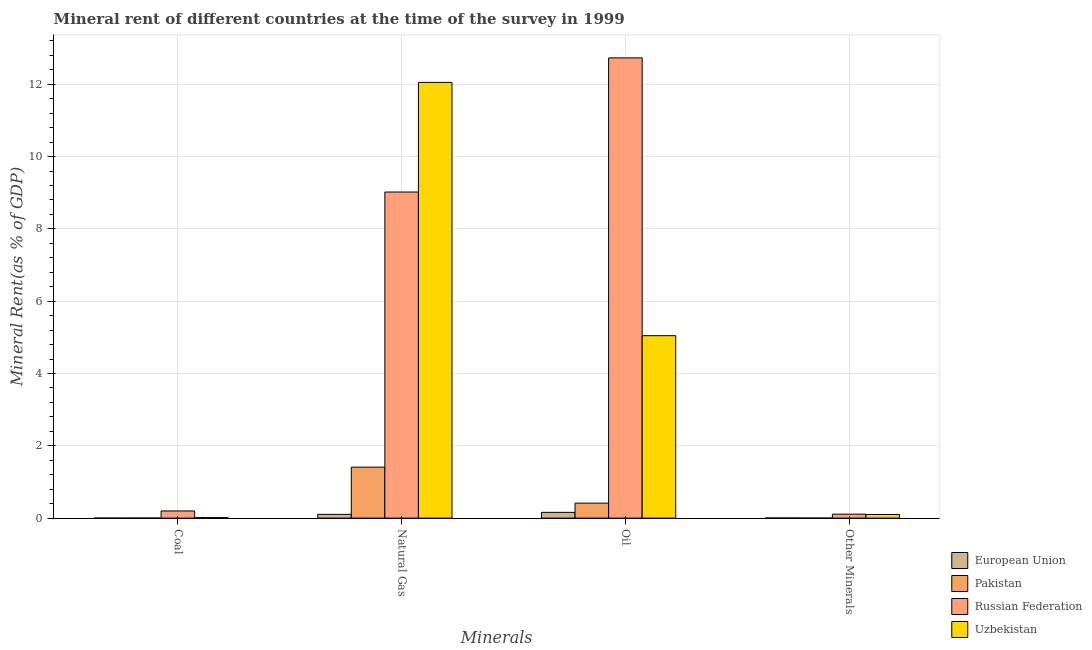How many different coloured bars are there?
Ensure brevity in your answer.  4. Are the number of bars per tick equal to the number of legend labels?
Make the answer very short. Yes. Are the number of bars on each tick of the X-axis equal?
Provide a succinct answer. Yes. How many bars are there on the 4th tick from the left?
Make the answer very short. 4. How many bars are there on the 3rd tick from the right?
Make the answer very short. 4. What is the label of the 4th group of bars from the left?
Keep it short and to the point. Other Minerals. What is the coal rent in Uzbekistan?
Your answer should be compact. 0.01. Across all countries, what is the maximum coal rent?
Your answer should be compact. 0.2. Across all countries, what is the minimum  rent of other minerals?
Your answer should be compact. 0. In which country was the oil rent maximum?
Offer a very short reply. Russian Federation. What is the total oil rent in the graph?
Keep it short and to the point. 18.35. What is the difference between the oil rent in Uzbekistan and that in Pakistan?
Your answer should be compact. 4.63. What is the difference between the natural gas rent in Uzbekistan and the coal rent in Pakistan?
Offer a terse response. 12.05. What is the average  rent of other minerals per country?
Offer a terse response. 0.05. What is the difference between the natural gas rent and oil rent in Uzbekistan?
Keep it short and to the point. 7.01. What is the ratio of the natural gas rent in European Union to that in Uzbekistan?
Ensure brevity in your answer.  0.01. Is the difference between the coal rent in Uzbekistan and European Union greater than the difference between the oil rent in Uzbekistan and European Union?
Your response must be concise. No. What is the difference between the highest and the second highest  rent of other minerals?
Keep it short and to the point. 0.01. What is the difference between the highest and the lowest oil rent?
Offer a very short reply. 12.57. Is it the case that in every country, the sum of the  rent of other minerals and coal rent is greater than the sum of oil rent and natural gas rent?
Your answer should be very brief. No. What does the 3rd bar from the left in Coal represents?
Give a very brief answer. Russian Federation. What does the 1st bar from the right in Other Minerals represents?
Offer a terse response. Uzbekistan. Is it the case that in every country, the sum of the coal rent and natural gas rent is greater than the oil rent?
Provide a succinct answer. No. Are all the bars in the graph horizontal?
Provide a succinct answer. No. How many countries are there in the graph?
Offer a terse response. 4. Are the values on the major ticks of Y-axis written in scientific E-notation?
Your response must be concise. No. Does the graph contain any zero values?
Ensure brevity in your answer.  No. Does the graph contain grids?
Your answer should be very brief. Yes. Where does the legend appear in the graph?
Your response must be concise. Bottom right. What is the title of the graph?
Give a very brief answer. Mineral rent of different countries at the time of the survey in 1999. Does "St. Kitts and Nevis" appear as one of the legend labels in the graph?
Offer a terse response. No. What is the label or title of the X-axis?
Your response must be concise. Minerals. What is the label or title of the Y-axis?
Your response must be concise. Mineral Rent(as % of GDP). What is the Mineral Rent(as % of GDP) in European Union in Coal?
Your response must be concise. 7.968829103317441e-5. What is the Mineral Rent(as % of GDP) of Pakistan in Coal?
Your answer should be compact. 0. What is the Mineral Rent(as % of GDP) of Russian Federation in Coal?
Your response must be concise. 0.2. What is the Mineral Rent(as % of GDP) of Uzbekistan in Coal?
Your response must be concise. 0.01. What is the Mineral Rent(as % of GDP) in European Union in Natural Gas?
Keep it short and to the point. 0.1. What is the Mineral Rent(as % of GDP) in Pakistan in Natural Gas?
Provide a succinct answer. 1.41. What is the Mineral Rent(as % of GDP) of Russian Federation in Natural Gas?
Provide a short and direct response. 9.02. What is the Mineral Rent(as % of GDP) in Uzbekistan in Natural Gas?
Your answer should be compact. 12.05. What is the Mineral Rent(as % of GDP) of European Union in Oil?
Keep it short and to the point. 0.16. What is the Mineral Rent(as % of GDP) in Pakistan in Oil?
Ensure brevity in your answer.  0.41. What is the Mineral Rent(as % of GDP) in Russian Federation in Oil?
Keep it short and to the point. 12.73. What is the Mineral Rent(as % of GDP) in Uzbekistan in Oil?
Ensure brevity in your answer.  5.05. What is the Mineral Rent(as % of GDP) in European Union in Other Minerals?
Your response must be concise. 0. What is the Mineral Rent(as % of GDP) of Pakistan in Other Minerals?
Your answer should be compact. 0. What is the Mineral Rent(as % of GDP) in Russian Federation in Other Minerals?
Offer a terse response. 0.11. What is the Mineral Rent(as % of GDP) of Uzbekistan in Other Minerals?
Give a very brief answer. 0.1. Across all Minerals, what is the maximum Mineral Rent(as % of GDP) in European Union?
Your response must be concise. 0.16. Across all Minerals, what is the maximum Mineral Rent(as % of GDP) of Pakistan?
Your answer should be very brief. 1.41. Across all Minerals, what is the maximum Mineral Rent(as % of GDP) of Russian Federation?
Keep it short and to the point. 12.73. Across all Minerals, what is the maximum Mineral Rent(as % of GDP) in Uzbekistan?
Provide a succinct answer. 12.05. Across all Minerals, what is the minimum Mineral Rent(as % of GDP) of European Union?
Keep it short and to the point. 7.968829103317441e-5. Across all Minerals, what is the minimum Mineral Rent(as % of GDP) of Pakistan?
Make the answer very short. 0. Across all Minerals, what is the minimum Mineral Rent(as % of GDP) in Russian Federation?
Your answer should be compact. 0.11. Across all Minerals, what is the minimum Mineral Rent(as % of GDP) in Uzbekistan?
Ensure brevity in your answer.  0.01. What is the total Mineral Rent(as % of GDP) of European Union in the graph?
Offer a very short reply. 0.27. What is the total Mineral Rent(as % of GDP) of Pakistan in the graph?
Offer a terse response. 1.83. What is the total Mineral Rent(as % of GDP) of Russian Federation in the graph?
Provide a short and direct response. 22.06. What is the total Mineral Rent(as % of GDP) of Uzbekistan in the graph?
Give a very brief answer. 17.22. What is the difference between the Mineral Rent(as % of GDP) of European Union in Coal and that in Natural Gas?
Your response must be concise. -0.1. What is the difference between the Mineral Rent(as % of GDP) of Pakistan in Coal and that in Natural Gas?
Keep it short and to the point. -1.41. What is the difference between the Mineral Rent(as % of GDP) in Russian Federation in Coal and that in Natural Gas?
Give a very brief answer. -8.82. What is the difference between the Mineral Rent(as % of GDP) in Uzbekistan in Coal and that in Natural Gas?
Give a very brief answer. -12.04. What is the difference between the Mineral Rent(as % of GDP) in European Union in Coal and that in Oil?
Offer a very short reply. -0.16. What is the difference between the Mineral Rent(as % of GDP) of Pakistan in Coal and that in Oil?
Your answer should be compact. -0.41. What is the difference between the Mineral Rent(as % of GDP) in Russian Federation in Coal and that in Oil?
Make the answer very short. -12.53. What is the difference between the Mineral Rent(as % of GDP) of Uzbekistan in Coal and that in Oil?
Your response must be concise. -5.03. What is the difference between the Mineral Rent(as % of GDP) of European Union in Coal and that in Other Minerals?
Make the answer very short. -0. What is the difference between the Mineral Rent(as % of GDP) in Pakistan in Coal and that in Other Minerals?
Your response must be concise. 0. What is the difference between the Mineral Rent(as % of GDP) in Russian Federation in Coal and that in Other Minerals?
Offer a terse response. 0.09. What is the difference between the Mineral Rent(as % of GDP) in Uzbekistan in Coal and that in Other Minerals?
Provide a short and direct response. -0.09. What is the difference between the Mineral Rent(as % of GDP) of European Union in Natural Gas and that in Oil?
Your response must be concise. -0.05. What is the difference between the Mineral Rent(as % of GDP) of Pakistan in Natural Gas and that in Oil?
Ensure brevity in your answer.  1. What is the difference between the Mineral Rent(as % of GDP) in Russian Federation in Natural Gas and that in Oil?
Provide a succinct answer. -3.71. What is the difference between the Mineral Rent(as % of GDP) in Uzbekistan in Natural Gas and that in Oil?
Your answer should be very brief. 7.01. What is the difference between the Mineral Rent(as % of GDP) of European Union in Natural Gas and that in Other Minerals?
Your answer should be very brief. 0.1. What is the difference between the Mineral Rent(as % of GDP) in Pakistan in Natural Gas and that in Other Minerals?
Offer a terse response. 1.41. What is the difference between the Mineral Rent(as % of GDP) of Russian Federation in Natural Gas and that in Other Minerals?
Make the answer very short. 8.91. What is the difference between the Mineral Rent(as % of GDP) of Uzbekistan in Natural Gas and that in Other Minerals?
Provide a short and direct response. 11.95. What is the difference between the Mineral Rent(as % of GDP) in European Union in Oil and that in Other Minerals?
Your response must be concise. 0.16. What is the difference between the Mineral Rent(as % of GDP) of Pakistan in Oil and that in Other Minerals?
Give a very brief answer. 0.41. What is the difference between the Mineral Rent(as % of GDP) in Russian Federation in Oil and that in Other Minerals?
Provide a short and direct response. 12.62. What is the difference between the Mineral Rent(as % of GDP) in Uzbekistan in Oil and that in Other Minerals?
Keep it short and to the point. 4.95. What is the difference between the Mineral Rent(as % of GDP) in European Union in Coal and the Mineral Rent(as % of GDP) in Pakistan in Natural Gas?
Keep it short and to the point. -1.41. What is the difference between the Mineral Rent(as % of GDP) in European Union in Coal and the Mineral Rent(as % of GDP) in Russian Federation in Natural Gas?
Offer a terse response. -9.02. What is the difference between the Mineral Rent(as % of GDP) of European Union in Coal and the Mineral Rent(as % of GDP) of Uzbekistan in Natural Gas?
Ensure brevity in your answer.  -12.05. What is the difference between the Mineral Rent(as % of GDP) of Pakistan in Coal and the Mineral Rent(as % of GDP) of Russian Federation in Natural Gas?
Provide a short and direct response. -9.02. What is the difference between the Mineral Rent(as % of GDP) of Pakistan in Coal and the Mineral Rent(as % of GDP) of Uzbekistan in Natural Gas?
Your answer should be very brief. -12.05. What is the difference between the Mineral Rent(as % of GDP) in Russian Federation in Coal and the Mineral Rent(as % of GDP) in Uzbekistan in Natural Gas?
Keep it short and to the point. -11.86. What is the difference between the Mineral Rent(as % of GDP) of European Union in Coal and the Mineral Rent(as % of GDP) of Pakistan in Oil?
Your answer should be very brief. -0.41. What is the difference between the Mineral Rent(as % of GDP) in European Union in Coal and the Mineral Rent(as % of GDP) in Russian Federation in Oil?
Give a very brief answer. -12.73. What is the difference between the Mineral Rent(as % of GDP) in European Union in Coal and the Mineral Rent(as % of GDP) in Uzbekistan in Oil?
Your answer should be very brief. -5.05. What is the difference between the Mineral Rent(as % of GDP) of Pakistan in Coal and the Mineral Rent(as % of GDP) of Russian Federation in Oil?
Ensure brevity in your answer.  -12.73. What is the difference between the Mineral Rent(as % of GDP) in Pakistan in Coal and the Mineral Rent(as % of GDP) in Uzbekistan in Oil?
Provide a short and direct response. -5.05. What is the difference between the Mineral Rent(as % of GDP) in Russian Federation in Coal and the Mineral Rent(as % of GDP) in Uzbekistan in Oil?
Give a very brief answer. -4.85. What is the difference between the Mineral Rent(as % of GDP) of European Union in Coal and the Mineral Rent(as % of GDP) of Pakistan in Other Minerals?
Provide a succinct answer. -0. What is the difference between the Mineral Rent(as % of GDP) of European Union in Coal and the Mineral Rent(as % of GDP) of Russian Federation in Other Minerals?
Your answer should be very brief. -0.11. What is the difference between the Mineral Rent(as % of GDP) in European Union in Coal and the Mineral Rent(as % of GDP) in Uzbekistan in Other Minerals?
Give a very brief answer. -0.1. What is the difference between the Mineral Rent(as % of GDP) in Pakistan in Coal and the Mineral Rent(as % of GDP) in Russian Federation in Other Minerals?
Keep it short and to the point. -0.11. What is the difference between the Mineral Rent(as % of GDP) of Pakistan in Coal and the Mineral Rent(as % of GDP) of Uzbekistan in Other Minerals?
Provide a succinct answer. -0.1. What is the difference between the Mineral Rent(as % of GDP) in Russian Federation in Coal and the Mineral Rent(as % of GDP) in Uzbekistan in Other Minerals?
Keep it short and to the point. 0.1. What is the difference between the Mineral Rent(as % of GDP) in European Union in Natural Gas and the Mineral Rent(as % of GDP) in Pakistan in Oil?
Ensure brevity in your answer.  -0.31. What is the difference between the Mineral Rent(as % of GDP) in European Union in Natural Gas and the Mineral Rent(as % of GDP) in Russian Federation in Oil?
Make the answer very short. -12.63. What is the difference between the Mineral Rent(as % of GDP) of European Union in Natural Gas and the Mineral Rent(as % of GDP) of Uzbekistan in Oil?
Your response must be concise. -4.94. What is the difference between the Mineral Rent(as % of GDP) in Pakistan in Natural Gas and the Mineral Rent(as % of GDP) in Russian Federation in Oil?
Offer a terse response. -11.32. What is the difference between the Mineral Rent(as % of GDP) in Pakistan in Natural Gas and the Mineral Rent(as % of GDP) in Uzbekistan in Oil?
Provide a short and direct response. -3.64. What is the difference between the Mineral Rent(as % of GDP) of Russian Federation in Natural Gas and the Mineral Rent(as % of GDP) of Uzbekistan in Oil?
Give a very brief answer. 3.97. What is the difference between the Mineral Rent(as % of GDP) of European Union in Natural Gas and the Mineral Rent(as % of GDP) of Pakistan in Other Minerals?
Offer a very short reply. 0.1. What is the difference between the Mineral Rent(as % of GDP) of European Union in Natural Gas and the Mineral Rent(as % of GDP) of Russian Federation in Other Minerals?
Your answer should be compact. -0. What is the difference between the Mineral Rent(as % of GDP) in European Union in Natural Gas and the Mineral Rent(as % of GDP) in Uzbekistan in Other Minerals?
Your answer should be compact. 0. What is the difference between the Mineral Rent(as % of GDP) in Pakistan in Natural Gas and the Mineral Rent(as % of GDP) in Russian Federation in Other Minerals?
Your response must be concise. 1.3. What is the difference between the Mineral Rent(as % of GDP) in Pakistan in Natural Gas and the Mineral Rent(as % of GDP) in Uzbekistan in Other Minerals?
Your answer should be compact. 1.31. What is the difference between the Mineral Rent(as % of GDP) in Russian Federation in Natural Gas and the Mineral Rent(as % of GDP) in Uzbekistan in Other Minerals?
Give a very brief answer. 8.92. What is the difference between the Mineral Rent(as % of GDP) in European Union in Oil and the Mineral Rent(as % of GDP) in Pakistan in Other Minerals?
Keep it short and to the point. 0.16. What is the difference between the Mineral Rent(as % of GDP) of European Union in Oil and the Mineral Rent(as % of GDP) of Russian Federation in Other Minerals?
Give a very brief answer. 0.05. What is the difference between the Mineral Rent(as % of GDP) of European Union in Oil and the Mineral Rent(as % of GDP) of Uzbekistan in Other Minerals?
Your response must be concise. 0.06. What is the difference between the Mineral Rent(as % of GDP) in Pakistan in Oil and the Mineral Rent(as % of GDP) in Russian Federation in Other Minerals?
Your answer should be very brief. 0.3. What is the difference between the Mineral Rent(as % of GDP) of Pakistan in Oil and the Mineral Rent(as % of GDP) of Uzbekistan in Other Minerals?
Your response must be concise. 0.31. What is the difference between the Mineral Rent(as % of GDP) in Russian Federation in Oil and the Mineral Rent(as % of GDP) in Uzbekistan in Other Minerals?
Ensure brevity in your answer.  12.63. What is the average Mineral Rent(as % of GDP) in European Union per Minerals?
Keep it short and to the point. 0.07. What is the average Mineral Rent(as % of GDP) of Pakistan per Minerals?
Offer a very short reply. 0.46. What is the average Mineral Rent(as % of GDP) in Russian Federation per Minerals?
Provide a succinct answer. 5.51. What is the average Mineral Rent(as % of GDP) of Uzbekistan per Minerals?
Offer a terse response. 4.3. What is the difference between the Mineral Rent(as % of GDP) in European Union and Mineral Rent(as % of GDP) in Pakistan in Coal?
Your response must be concise. -0. What is the difference between the Mineral Rent(as % of GDP) of European Union and Mineral Rent(as % of GDP) of Russian Federation in Coal?
Provide a succinct answer. -0.2. What is the difference between the Mineral Rent(as % of GDP) in European Union and Mineral Rent(as % of GDP) in Uzbekistan in Coal?
Make the answer very short. -0.01. What is the difference between the Mineral Rent(as % of GDP) of Pakistan and Mineral Rent(as % of GDP) of Russian Federation in Coal?
Keep it short and to the point. -0.2. What is the difference between the Mineral Rent(as % of GDP) in Pakistan and Mineral Rent(as % of GDP) in Uzbekistan in Coal?
Provide a short and direct response. -0.01. What is the difference between the Mineral Rent(as % of GDP) in Russian Federation and Mineral Rent(as % of GDP) in Uzbekistan in Coal?
Ensure brevity in your answer.  0.18. What is the difference between the Mineral Rent(as % of GDP) in European Union and Mineral Rent(as % of GDP) in Pakistan in Natural Gas?
Give a very brief answer. -1.31. What is the difference between the Mineral Rent(as % of GDP) of European Union and Mineral Rent(as % of GDP) of Russian Federation in Natural Gas?
Provide a short and direct response. -8.92. What is the difference between the Mineral Rent(as % of GDP) in European Union and Mineral Rent(as % of GDP) in Uzbekistan in Natural Gas?
Your answer should be very brief. -11.95. What is the difference between the Mineral Rent(as % of GDP) of Pakistan and Mineral Rent(as % of GDP) of Russian Federation in Natural Gas?
Give a very brief answer. -7.61. What is the difference between the Mineral Rent(as % of GDP) in Pakistan and Mineral Rent(as % of GDP) in Uzbekistan in Natural Gas?
Give a very brief answer. -10.64. What is the difference between the Mineral Rent(as % of GDP) in Russian Federation and Mineral Rent(as % of GDP) in Uzbekistan in Natural Gas?
Provide a short and direct response. -3.03. What is the difference between the Mineral Rent(as % of GDP) in European Union and Mineral Rent(as % of GDP) in Pakistan in Oil?
Provide a succinct answer. -0.26. What is the difference between the Mineral Rent(as % of GDP) in European Union and Mineral Rent(as % of GDP) in Russian Federation in Oil?
Provide a succinct answer. -12.57. What is the difference between the Mineral Rent(as % of GDP) in European Union and Mineral Rent(as % of GDP) in Uzbekistan in Oil?
Your answer should be very brief. -4.89. What is the difference between the Mineral Rent(as % of GDP) in Pakistan and Mineral Rent(as % of GDP) in Russian Federation in Oil?
Your answer should be very brief. -12.32. What is the difference between the Mineral Rent(as % of GDP) of Pakistan and Mineral Rent(as % of GDP) of Uzbekistan in Oil?
Your response must be concise. -4.63. What is the difference between the Mineral Rent(as % of GDP) in Russian Federation and Mineral Rent(as % of GDP) in Uzbekistan in Oil?
Your response must be concise. 7.68. What is the difference between the Mineral Rent(as % of GDP) of European Union and Mineral Rent(as % of GDP) of Pakistan in Other Minerals?
Offer a very short reply. 0. What is the difference between the Mineral Rent(as % of GDP) in European Union and Mineral Rent(as % of GDP) in Russian Federation in Other Minerals?
Ensure brevity in your answer.  -0.11. What is the difference between the Mineral Rent(as % of GDP) in European Union and Mineral Rent(as % of GDP) in Uzbekistan in Other Minerals?
Your response must be concise. -0.1. What is the difference between the Mineral Rent(as % of GDP) of Pakistan and Mineral Rent(as % of GDP) of Russian Federation in Other Minerals?
Offer a terse response. -0.11. What is the difference between the Mineral Rent(as % of GDP) of Pakistan and Mineral Rent(as % of GDP) of Uzbekistan in Other Minerals?
Offer a very short reply. -0.1. What is the difference between the Mineral Rent(as % of GDP) in Russian Federation and Mineral Rent(as % of GDP) in Uzbekistan in Other Minerals?
Your response must be concise. 0.01. What is the ratio of the Mineral Rent(as % of GDP) of European Union in Coal to that in Natural Gas?
Offer a terse response. 0. What is the ratio of the Mineral Rent(as % of GDP) in Pakistan in Coal to that in Natural Gas?
Provide a short and direct response. 0. What is the ratio of the Mineral Rent(as % of GDP) in Russian Federation in Coal to that in Natural Gas?
Your answer should be very brief. 0.02. What is the ratio of the Mineral Rent(as % of GDP) of Uzbekistan in Coal to that in Natural Gas?
Your answer should be compact. 0. What is the ratio of the Mineral Rent(as % of GDP) in Pakistan in Coal to that in Oil?
Make the answer very short. 0. What is the ratio of the Mineral Rent(as % of GDP) of Russian Federation in Coal to that in Oil?
Make the answer very short. 0.02. What is the ratio of the Mineral Rent(as % of GDP) of Uzbekistan in Coal to that in Oil?
Give a very brief answer. 0. What is the ratio of the Mineral Rent(as % of GDP) in European Union in Coal to that in Other Minerals?
Make the answer very short. 0.03. What is the ratio of the Mineral Rent(as % of GDP) of Pakistan in Coal to that in Other Minerals?
Keep it short and to the point. 4.99. What is the ratio of the Mineral Rent(as % of GDP) of Russian Federation in Coal to that in Other Minerals?
Make the answer very short. 1.81. What is the ratio of the Mineral Rent(as % of GDP) in Uzbekistan in Coal to that in Other Minerals?
Offer a very short reply. 0.14. What is the ratio of the Mineral Rent(as % of GDP) in European Union in Natural Gas to that in Oil?
Provide a short and direct response. 0.66. What is the ratio of the Mineral Rent(as % of GDP) in Pakistan in Natural Gas to that in Oil?
Make the answer very short. 3.4. What is the ratio of the Mineral Rent(as % of GDP) in Russian Federation in Natural Gas to that in Oil?
Provide a succinct answer. 0.71. What is the ratio of the Mineral Rent(as % of GDP) in Uzbekistan in Natural Gas to that in Oil?
Your response must be concise. 2.39. What is the ratio of the Mineral Rent(as % of GDP) in European Union in Natural Gas to that in Other Minerals?
Your answer should be compact. 40.79. What is the ratio of the Mineral Rent(as % of GDP) of Pakistan in Natural Gas to that in Other Minerals?
Provide a short and direct response. 6463.25. What is the ratio of the Mineral Rent(as % of GDP) of Russian Federation in Natural Gas to that in Other Minerals?
Provide a short and direct response. 82.56. What is the ratio of the Mineral Rent(as % of GDP) of Uzbekistan in Natural Gas to that in Other Minerals?
Your response must be concise. 119.27. What is the ratio of the Mineral Rent(as % of GDP) of European Union in Oil to that in Other Minerals?
Give a very brief answer. 62.14. What is the ratio of the Mineral Rent(as % of GDP) in Pakistan in Oil to that in Other Minerals?
Provide a short and direct response. 1899.49. What is the ratio of the Mineral Rent(as % of GDP) of Russian Federation in Oil to that in Other Minerals?
Your answer should be very brief. 116.52. What is the ratio of the Mineral Rent(as % of GDP) in Uzbekistan in Oil to that in Other Minerals?
Give a very brief answer. 49.94. What is the difference between the highest and the second highest Mineral Rent(as % of GDP) in European Union?
Your answer should be very brief. 0.05. What is the difference between the highest and the second highest Mineral Rent(as % of GDP) of Russian Federation?
Your answer should be compact. 3.71. What is the difference between the highest and the second highest Mineral Rent(as % of GDP) in Uzbekistan?
Your response must be concise. 7.01. What is the difference between the highest and the lowest Mineral Rent(as % of GDP) of European Union?
Offer a very short reply. 0.16. What is the difference between the highest and the lowest Mineral Rent(as % of GDP) of Pakistan?
Keep it short and to the point. 1.41. What is the difference between the highest and the lowest Mineral Rent(as % of GDP) in Russian Federation?
Offer a very short reply. 12.62. What is the difference between the highest and the lowest Mineral Rent(as % of GDP) of Uzbekistan?
Provide a short and direct response. 12.04. 